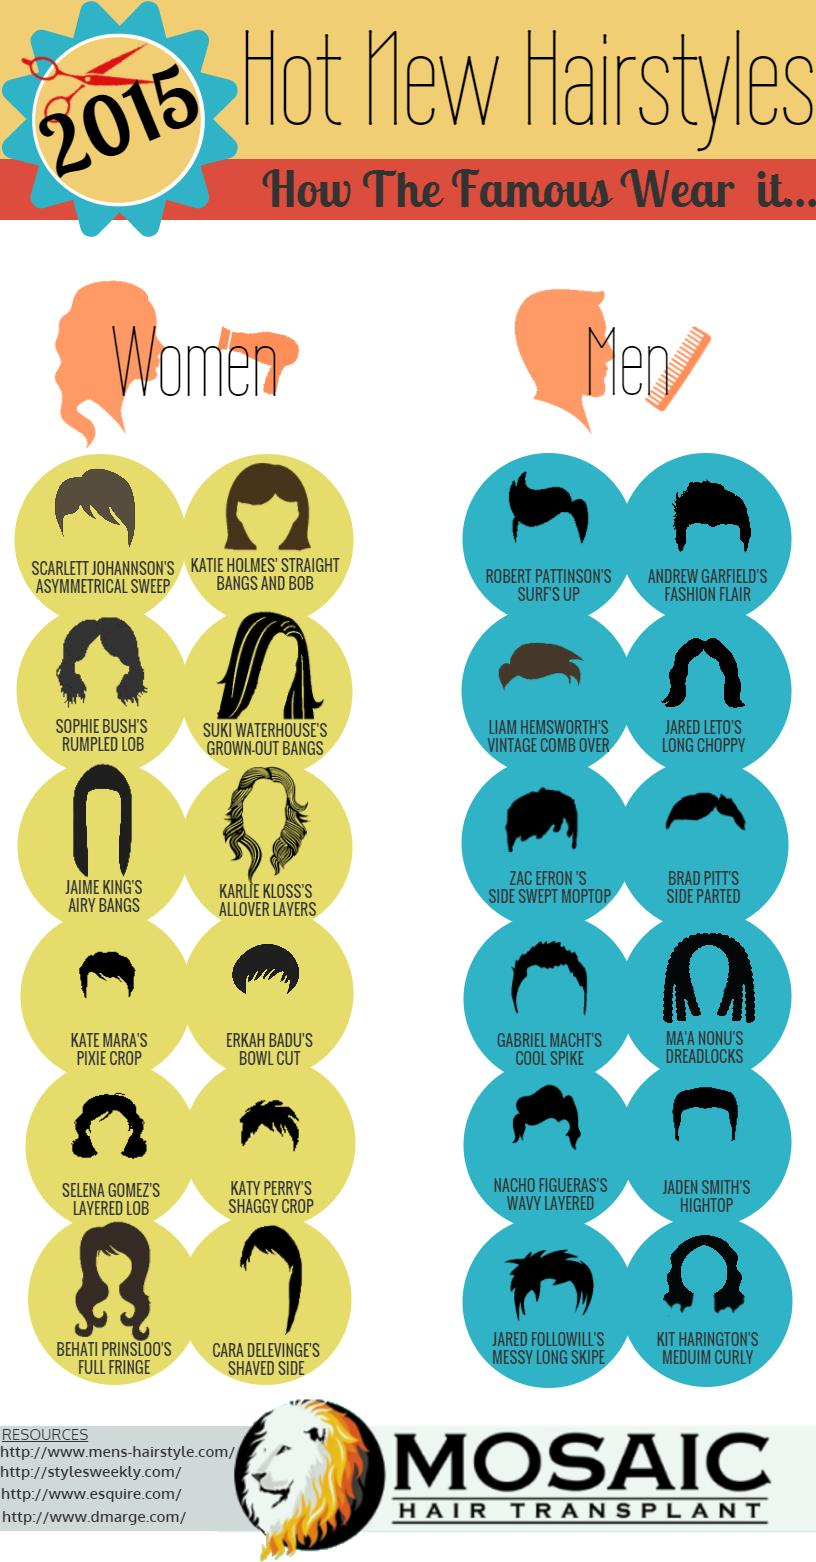Highlight a few significant elements in this photo. There are four short hair styles available for women. Erkah Badu has a hairstyle that resembles a bowl. BRAD PITT is known for wearing a side parted hairstyle. Jared Leto wears a hairstyle known as "long choppy" hair. The hairstyle worn by Katy Perry is called "shaggy crop. 